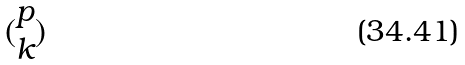<formula> <loc_0><loc_0><loc_500><loc_500>( \begin{matrix} p \\ k \end{matrix} )</formula> 